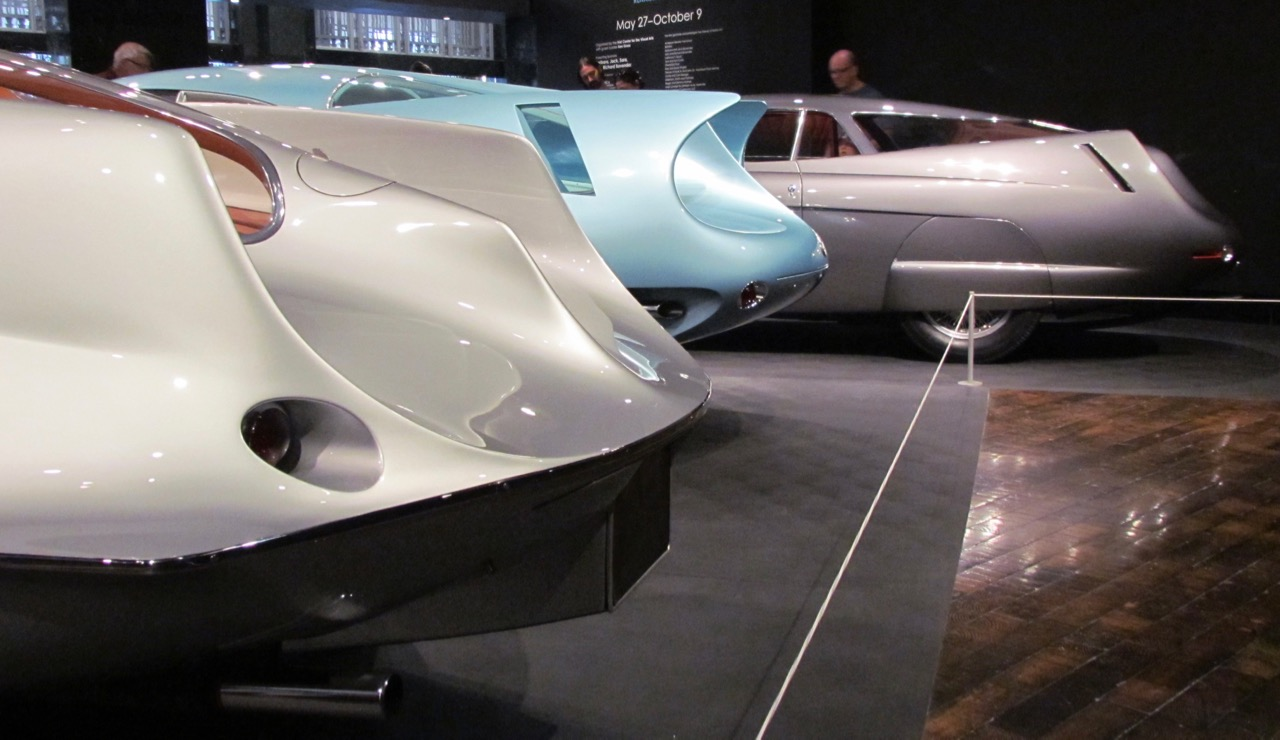Considering their unique and futuristic design, in what type of scenario would you envision seeing these cars? These cars would fit perfectly in a retro-futuristic cityscape, reminiscent of classic science fiction films. Picture them cruising through wide, sleek, reflective streets, surrounded by towering, curved skyscrapers and neon lights. The cars would glide smoothly and silently, embodying both the nostalgia for mid-20th-century optimism and a vision of a technologically advanced future. Alternatively, these cars could be the centerpiece of a high-end, exclusive automotive museum exhibit, drawing enthusiasts and designers eager to explore the innovative blend of art and engineering that defined an iconic era in automotive history. If you had to think of a practical modern-day use for these designs, what would it be? A practical modern-day use for these designs could be in the realm of electric vehicles. Utilizing their aerodynamic shapes, these cars would significantly enhance battery efficiency and range. They could serve as luxury electric sports cars, attracting those who value both performance and aesthetic excellence. Additionally, incorporating modern materials and technologies, such as lightweight composites and regenerative braking systems, would further enhance their performance and sustainability, making them icons of modern innovation inspired by historical design principles. 